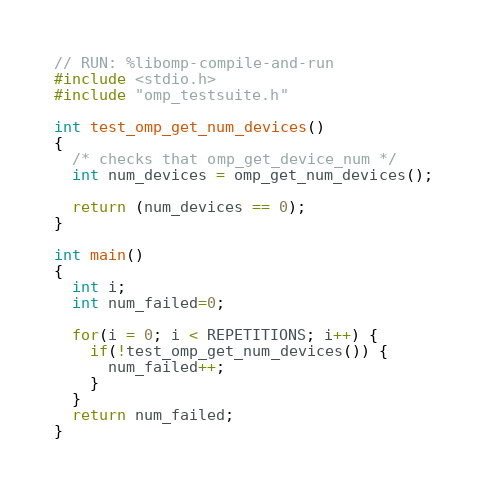<code> <loc_0><loc_0><loc_500><loc_500><_C_>// RUN: %libomp-compile-and-run
#include <stdio.h>
#include "omp_testsuite.h"

int test_omp_get_num_devices()
{
  /* checks that omp_get_device_num */
  int num_devices = omp_get_num_devices();

  return (num_devices == 0);
}

int main()
{
  int i;
  int num_failed=0;

  for(i = 0; i < REPETITIONS; i++) {
    if(!test_omp_get_num_devices()) {
      num_failed++;
    }
  }
  return num_failed;
}
</code> 